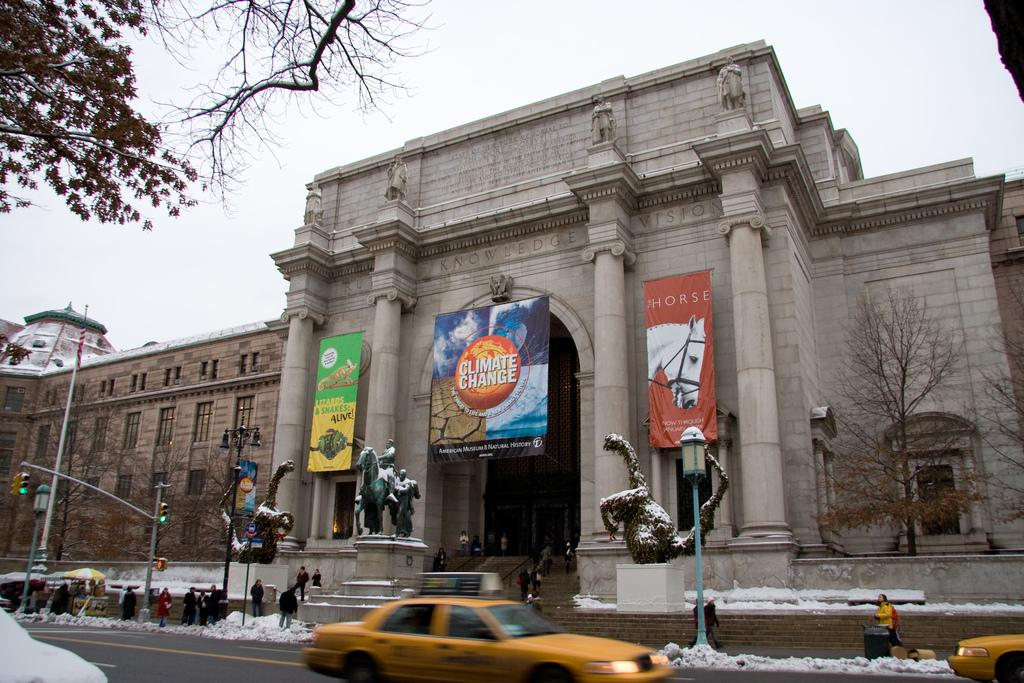<image>
Give a short and clear explanation of the subsequent image. A large building with several statues in front displays banners that say "Lizards & Snakes Alive!", "Climate Change", and "Horse". 